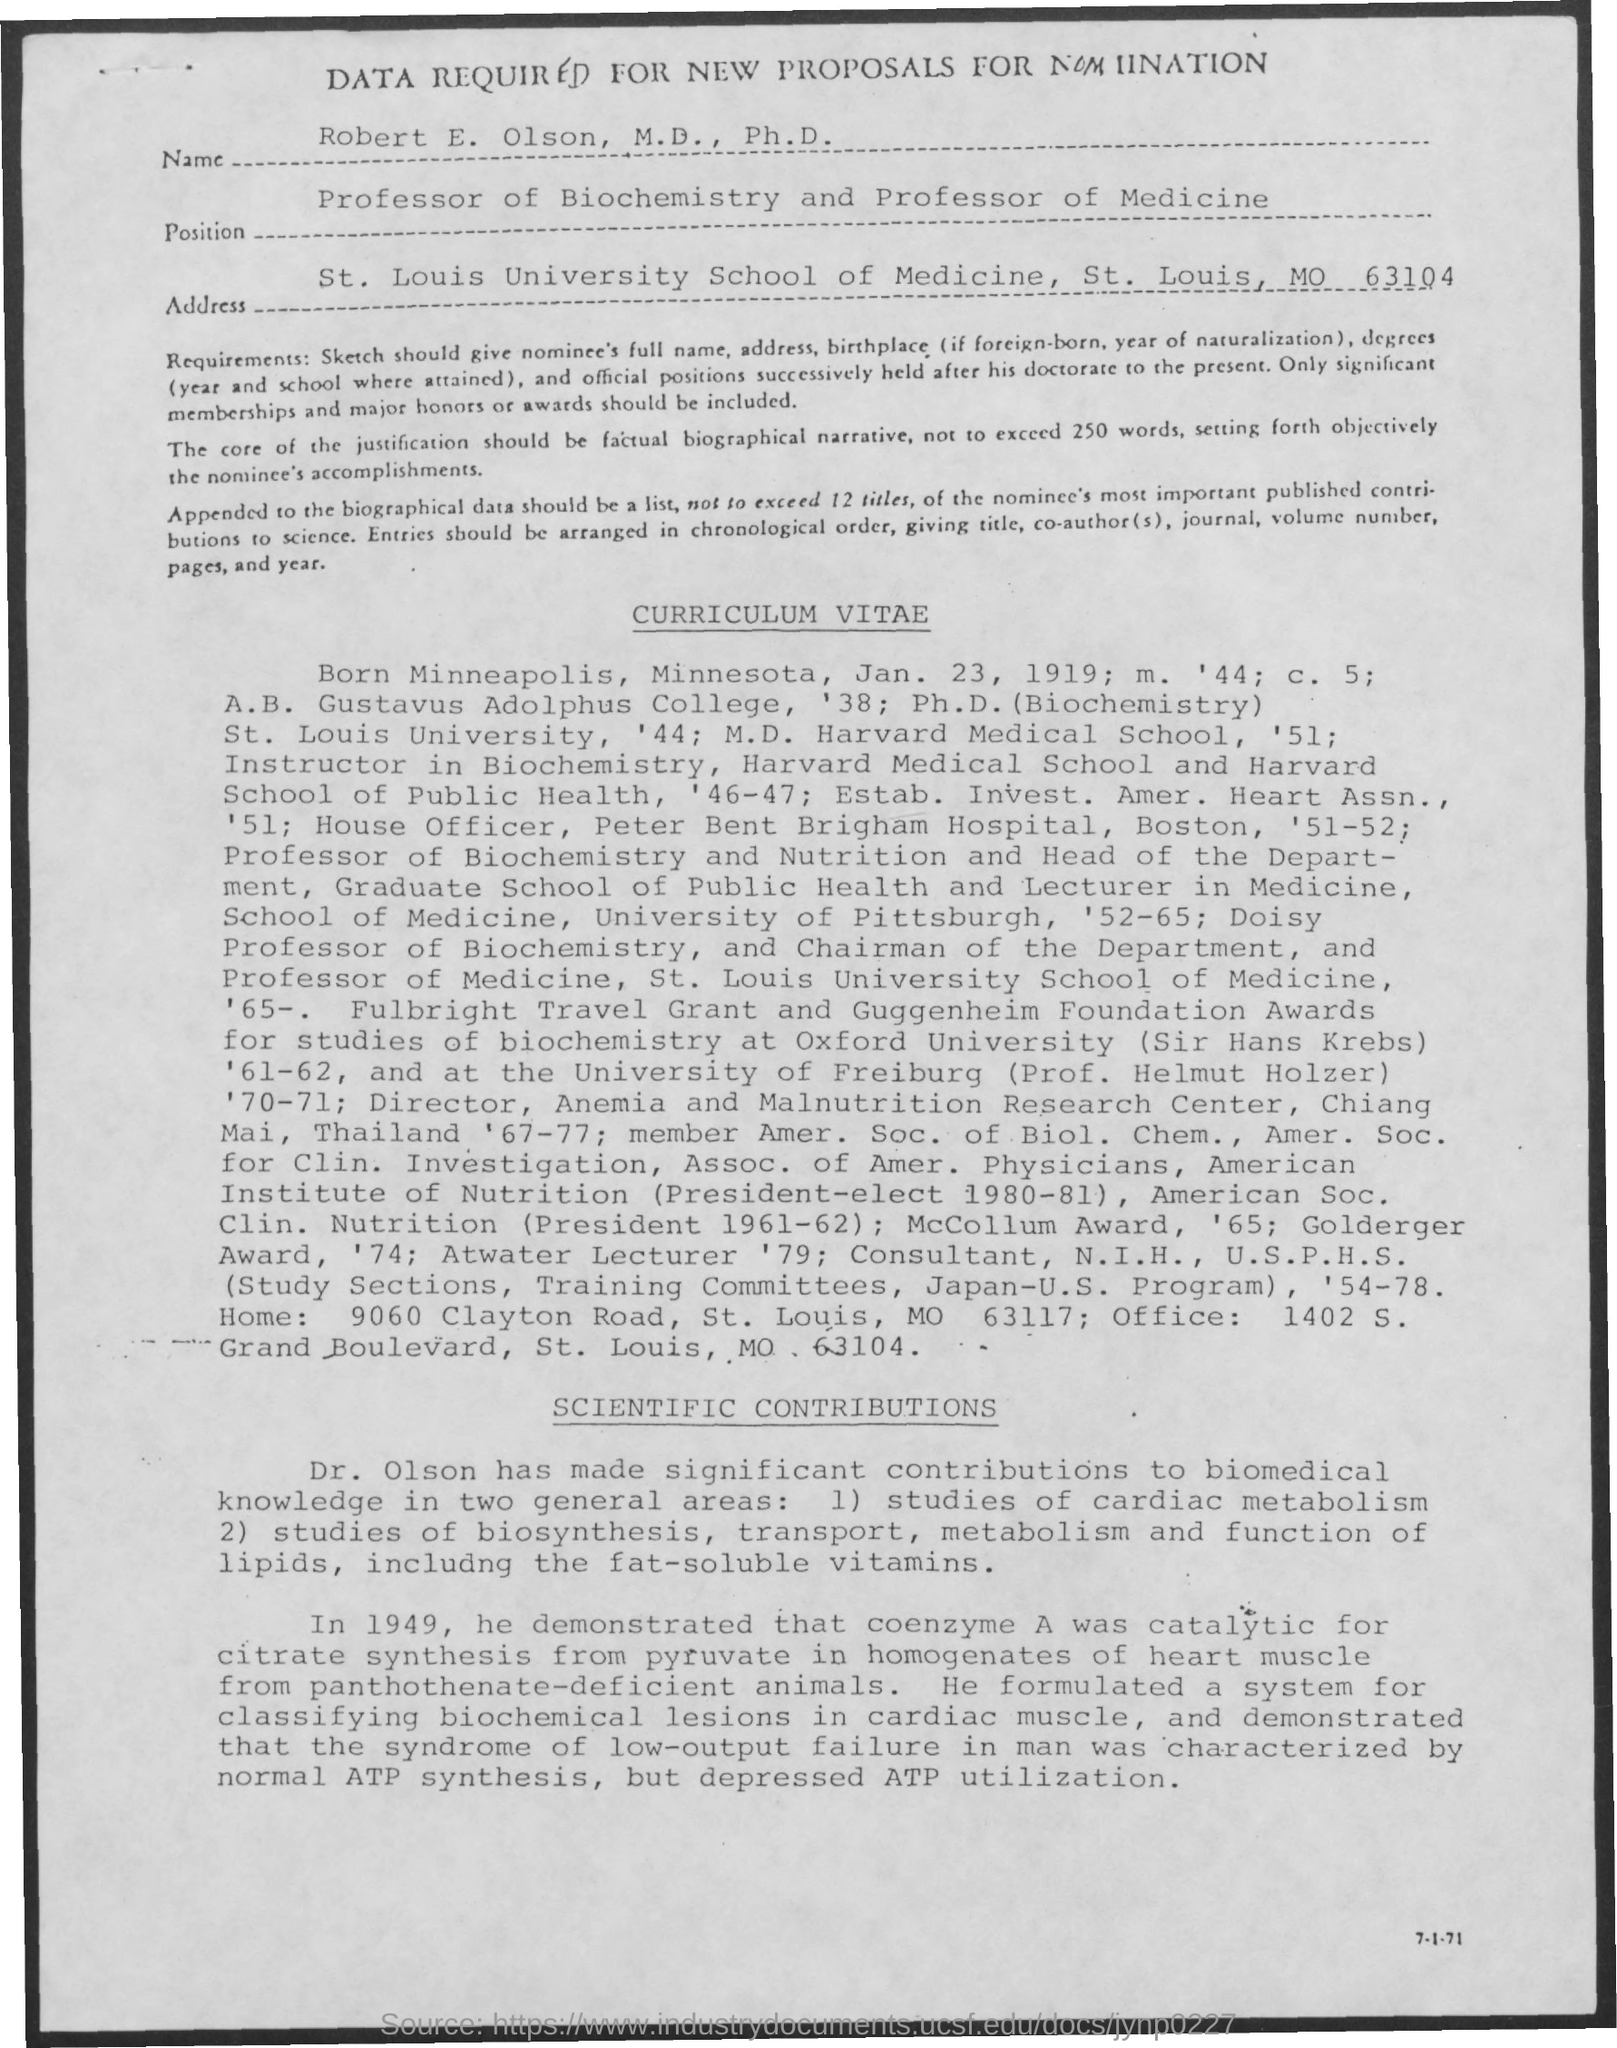What is the date mentioned in the curriculum vitae
Offer a very short reply. Jan. 23, 1919. 